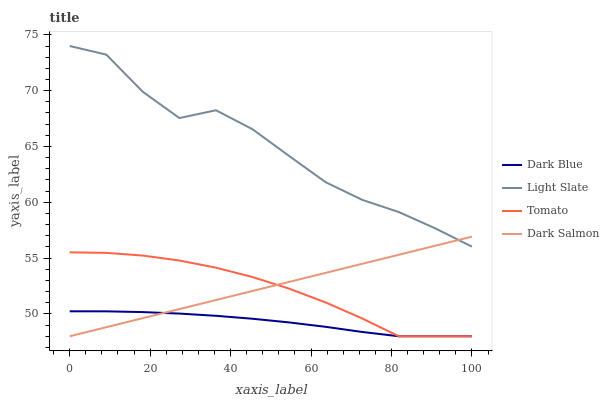Does Dark Blue have the minimum area under the curve?
Answer yes or no. Yes. Does Light Slate have the maximum area under the curve?
Answer yes or no. Yes. Does Tomato have the minimum area under the curve?
Answer yes or no. No. Does Tomato have the maximum area under the curve?
Answer yes or no. No. Is Dark Salmon the smoothest?
Answer yes or no. Yes. Is Light Slate the roughest?
Answer yes or no. Yes. Is Dark Blue the smoothest?
Answer yes or no. No. Is Dark Blue the roughest?
Answer yes or no. No. Does Dark Blue have the lowest value?
Answer yes or no. Yes. Does Light Slate have the highest value?
Answer yes or no. Yes. Does Tomato have the highest value?
Answer yes or no. No. Is Dark Blue less than Light Slate?
Answer yes or no. Yes. Is Light Slate greater than Tomato?
Answer yes or no. Yes. Does Dark Blue intersect Dark Salmon?
Answer yes or no. Yes. Is Dark Blue less than Dark Salmon?
Answer yes or no. No. Is Dark Blue greater than Dark Salmon?
Answer yes or no. No. Does Dark Blue intersect Light Slate?
Answer yes or no. No. 